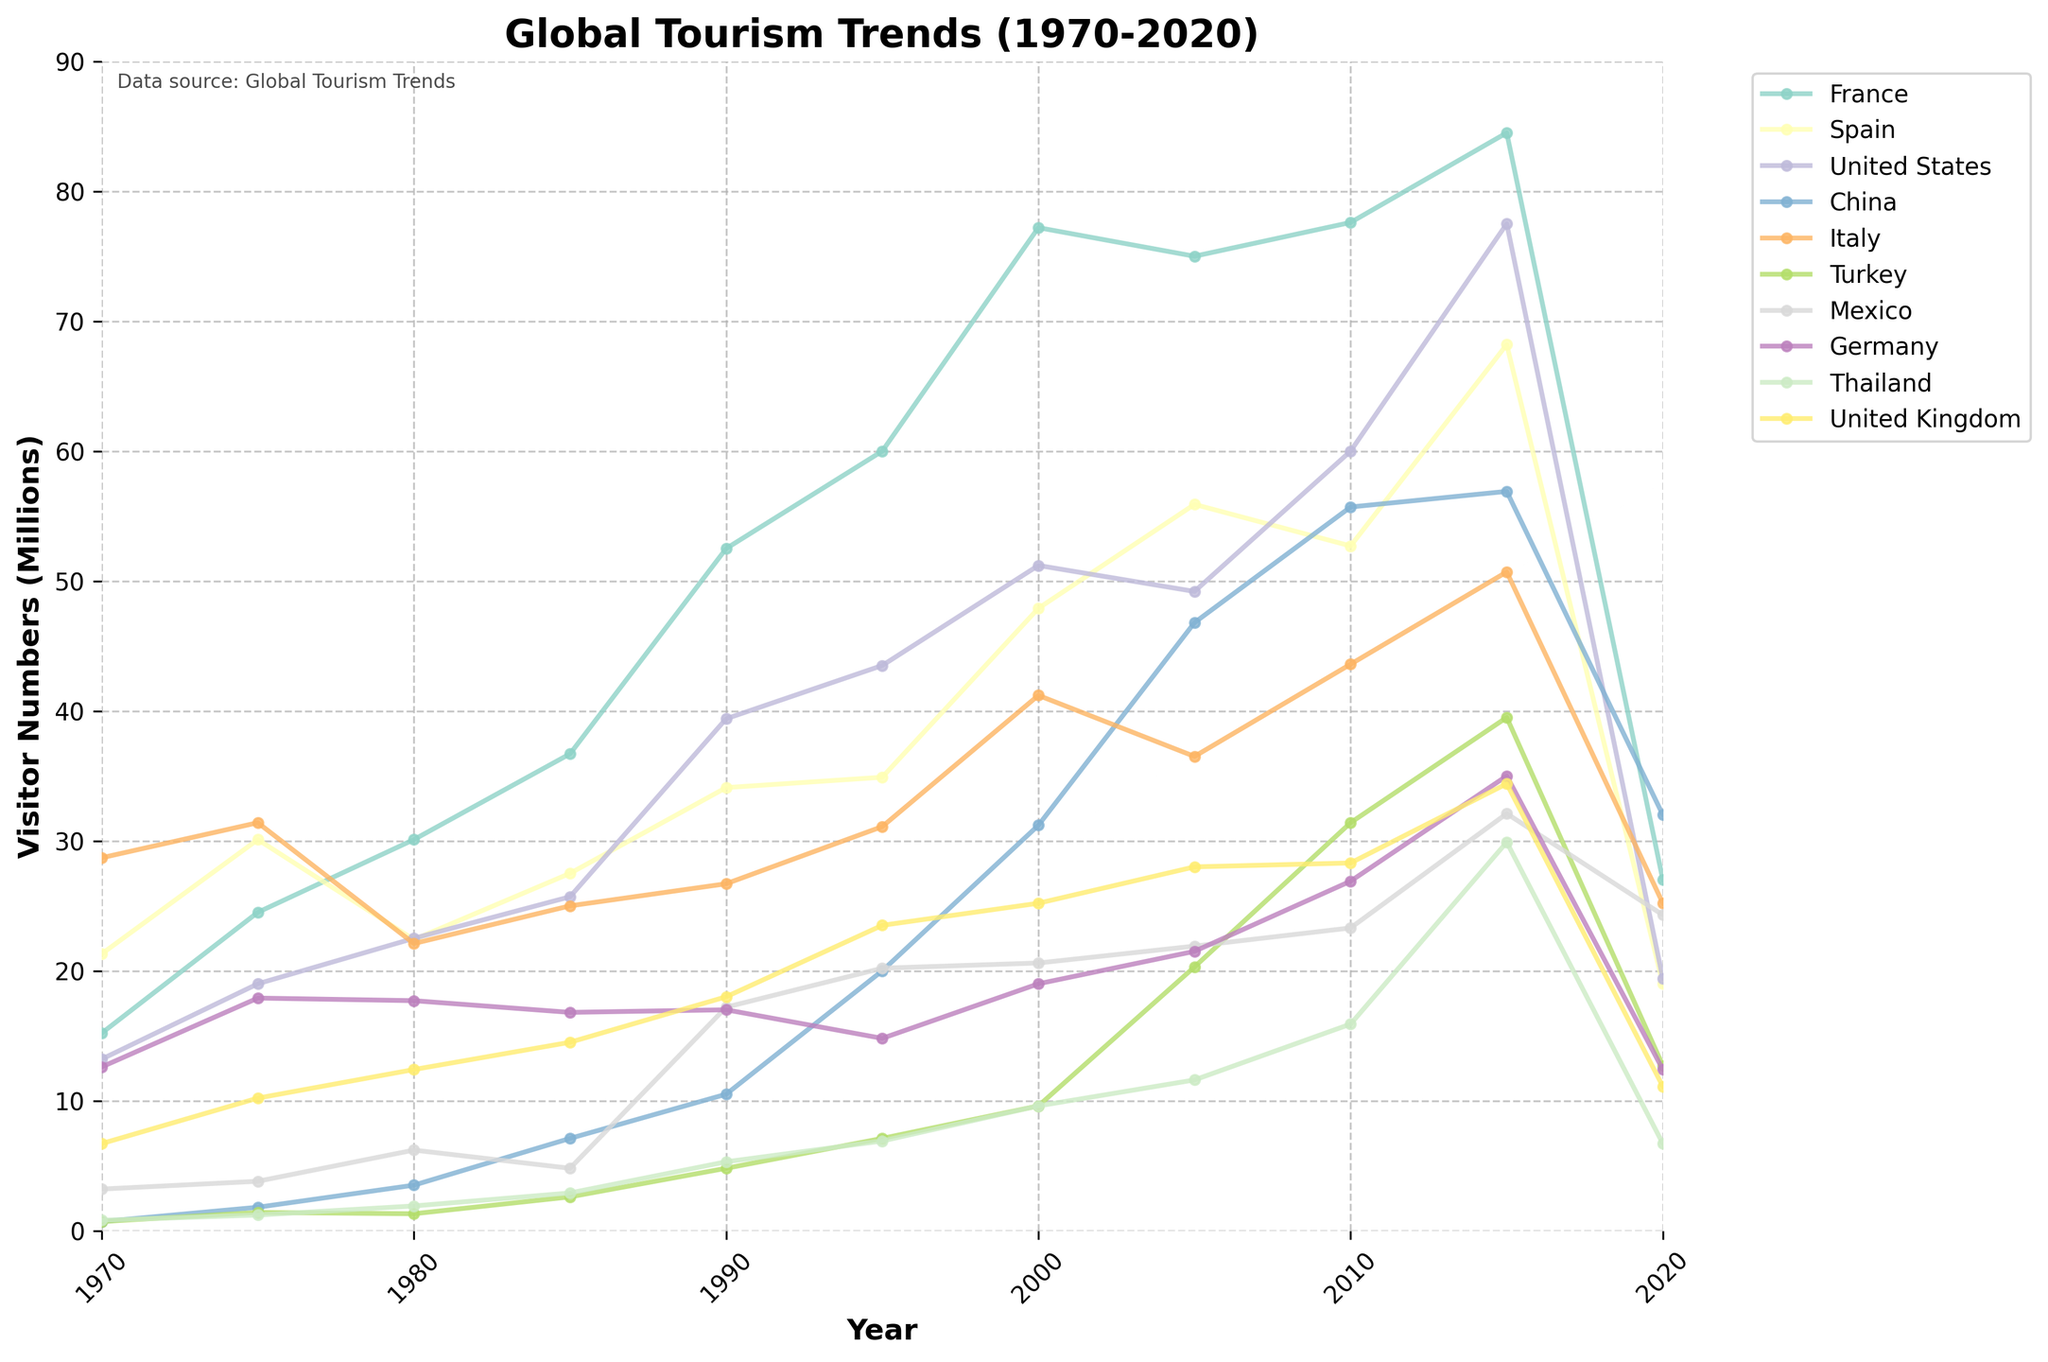What year did France see its highest number of visitors? By observing the line representing France in the figure, we can see the highest point corresponds to the year 2015.
Answer: 2015 How did visitor numbers to the United States change from 1970 to 2000? The visitor numbers increased from 13.2 million in 1970 to 51.2 million in 2000, which is an increment of 38.0 million.
Answer: Increased by 38.0 million Which country had the highest number of visitors in 2020, and how many? By examining the 2020 segment, Spain had the highest number of visitors with 19.0 million.
Answer: Spain with 19.0 million What is the difference in visitor numbers between France and Thailand in 2015? In 2015, France had 84.5 million visitors, and Thailand had 29.9 million. The difference is 84.5 - 29.9 = 54.6 million.
Answer: 54.6 million Which country experienced the most significant drop in visitors from 2015 to 2020? From the figure, France shows a steep decline from 84.5 million in 2015 to 27.0 million in 2020, a decrease of 57.5 million.
Answer: France Between Italy and Turkey, which country had more visitors in 2005 and by how much? By comparing the values for 2005, Italy had 36.5 million visitors while Turkey had 20.3 million. Thus, Italy had 36.5 - 20.3 = 16.2 million more visitors.
Answer: Italy by 16.2 million What trend do you observe for China between 1980 and 2010? The figure shows that visitor numbers to China steadily increased from 3.5 million in 1980 to 55.7 million in 2010, indicating a significant growth trend.
Answer: Significant growth How does the number of visitors to the United Kingdom in 1975 compare to that in 1985? The figure shows the visitor numbers for the UK were 10.2 million in 1975 and 14.5 million in 1985, an increase of 4.3 million.
Answer: Increased by 4.3 million Which country had a peak in visitors in 2010, and what was the count? The United States had a peak in 2010 with 60.0 million visitors as indicated by the high point on the figure for that year.
Answer: United States with 60.0 million 